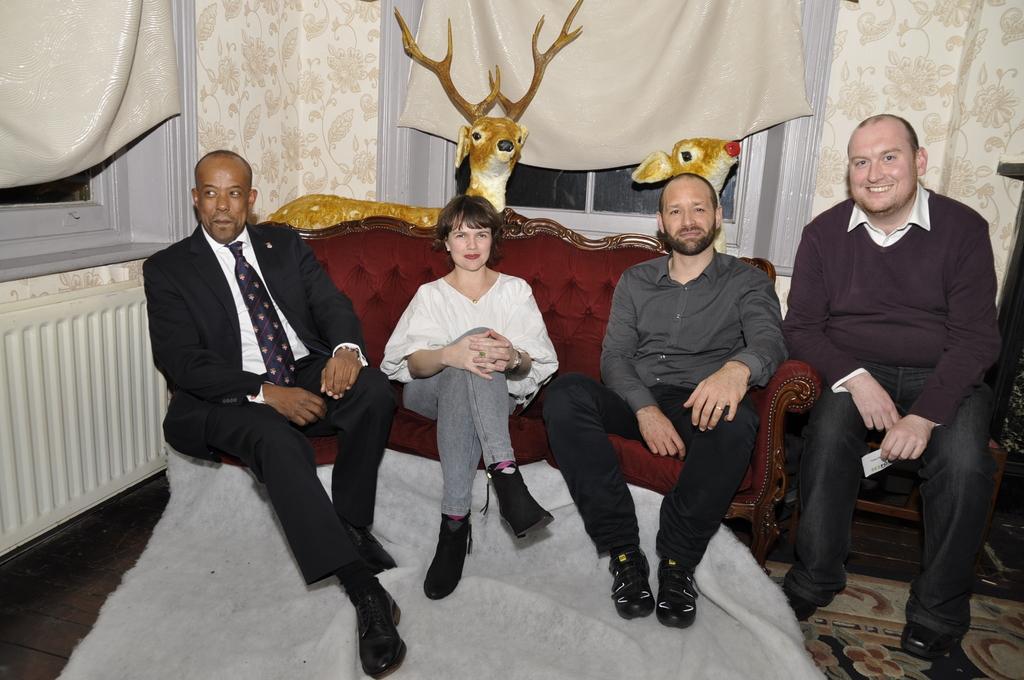Describe this image in one or two sentences. In this image we can see four persons sitting on the couch, one person is holding a card, there is a cloth, behind them there are dolls of deer, windows, curtains, also we can see the walls. 